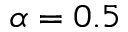<formula> <loc_0><loc_0><loc_500><loc_500>\alpha = 0 . 5</formula> 